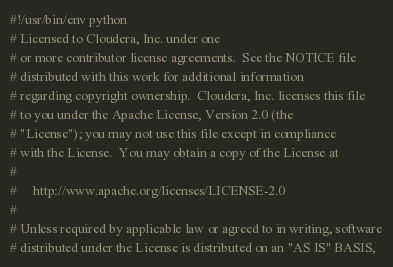Convert code to text. <code><loc_0><loc_0><loc_500><loc_500><_Python_>#!/usr/bin/env python
# Licensed to Cloudera, Inc. under one
# or more contributor license agreements.  See the NOTICE file
# distributed with this work for additional information
# regarding copyright ownership.  Cloudera, Inc. licenses this file
# to you under the Apache License, Version 2.0 (the
# "License"); you may not use this file except in compliance
# with the License.  You may obtain a copy of the License at
#
#     http://www.apache.org/licenses/LICENSE-2.0
#
# Unless required by applicable law or agreed to in writing, software
# distributed under the License is distributed on an "AS IS" BASIS,</code> 